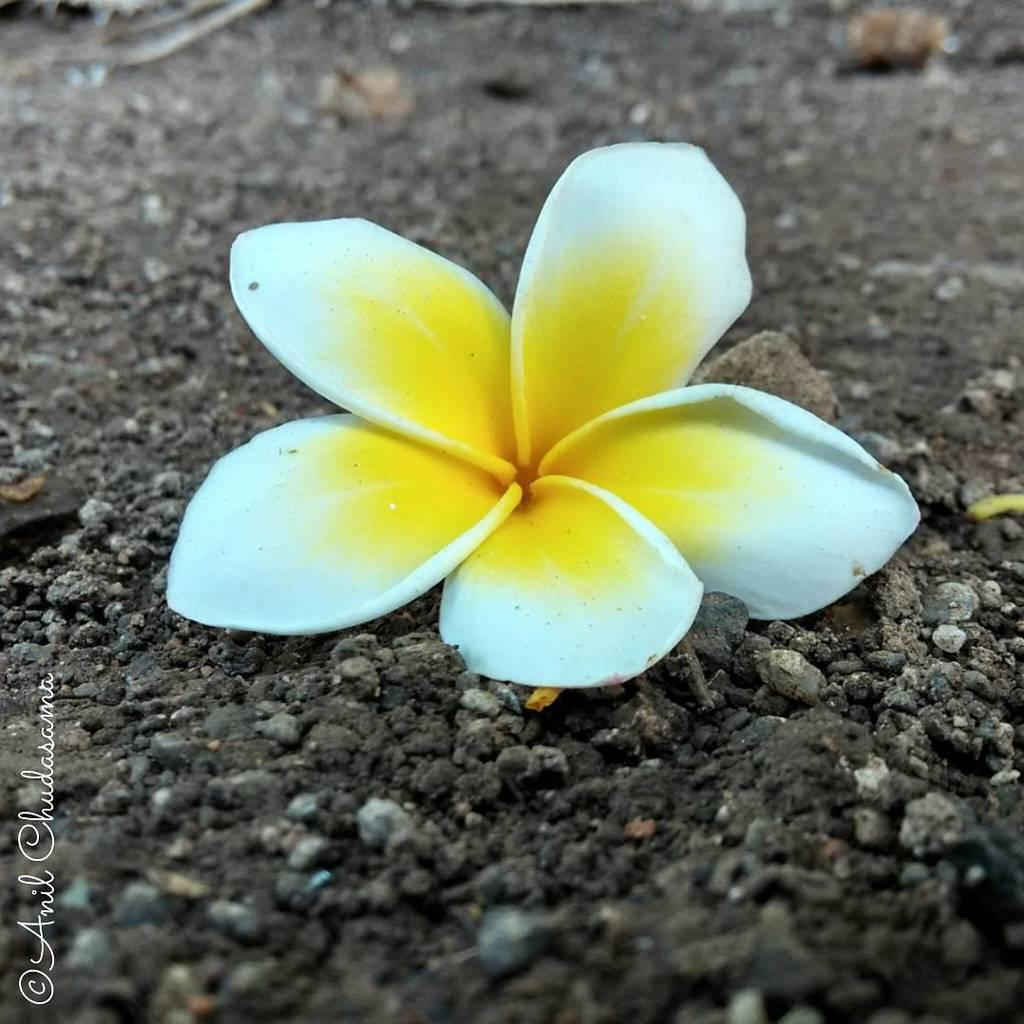What is present on the ground in the image? There is a flower on the ground in the image. Can you describe the appearance of the flower? The flower is yellow and white in color. Is the flower driving a car in the image? No, the flower is not driving a car in the image. There is no car or any indication of driving present in the image. 